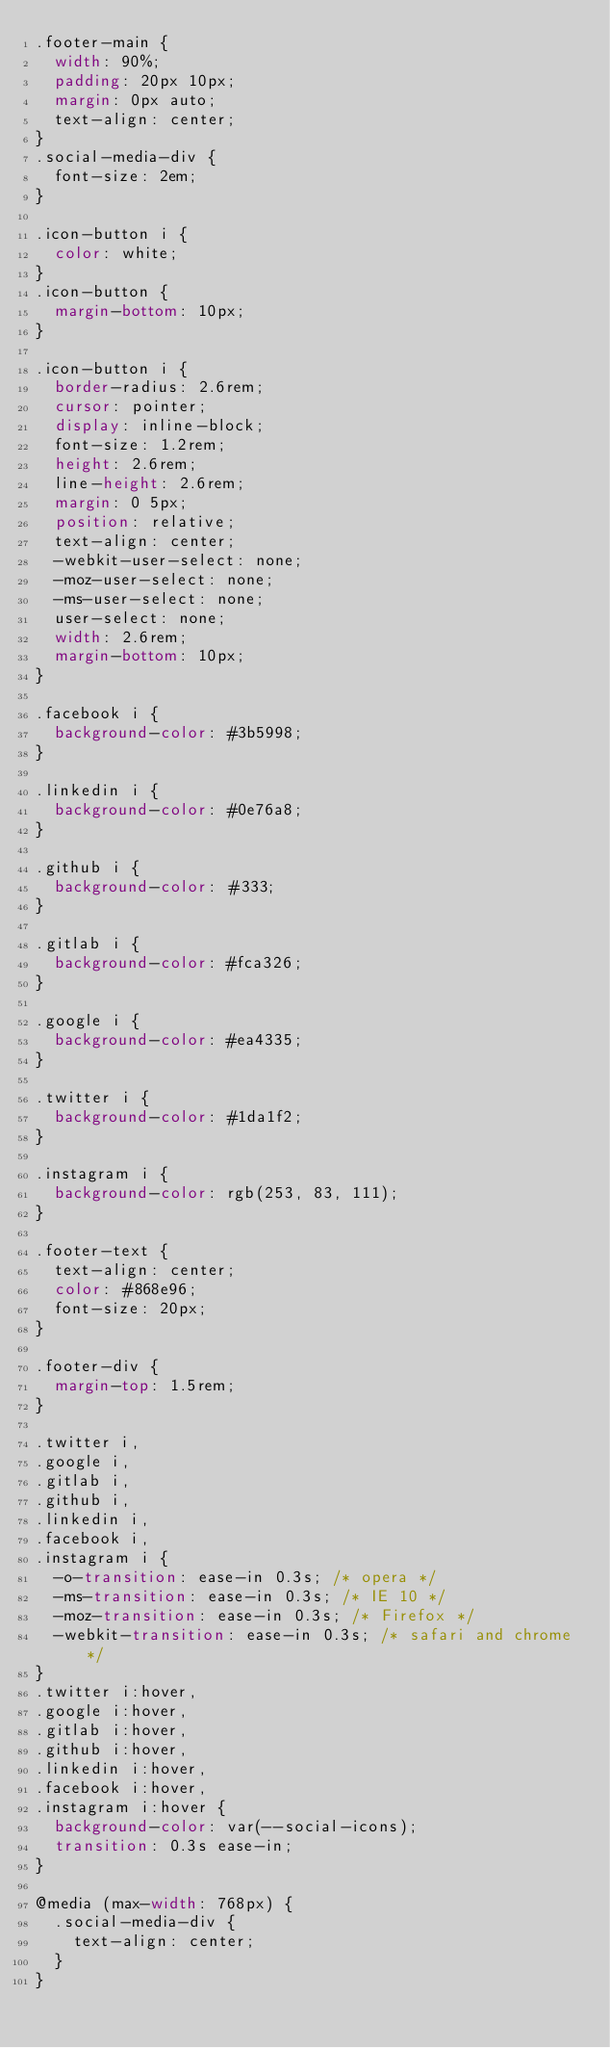<code> <loc_0><loc_0><loc_500><loc_500><_CSS_>.footer-main {
  width: 90%;
  padding: 20px 10px;
  margin: 0px auto;
  text-align: center;
}
.social-media-div {
  font-size: 2em;
}

.icon-button i {
  color: white;
}
.icon-button {
  margin-bottom: 10px;
}

.icon-button i {
  border-radius: 2.6rem;
  cursor: pointer;
  display: inline-block;
  font-size: 1.2rem;
  height: 2.6rem;
  line-height: 2.6rem;
  margin: 0 5px;
  position: relative;
  text-align: center;
  -webkit-user-select: none;
  -moz-user-select: none;
  -ms-user-select: none;
  user-select: none;
  width: 2.6rem;
  margin-bottom: 10px;
}

.facebook i {
  background-color: #3b5998;
}

.linkedin i {
  background-color: #0e76a8;
}

.github i {
  background-color: #333;
}

.gitlab i {
  background-color: #fca326;
}

.google i {
  background-color: #ea4335;
}

.twitter i {
  background-color: #1da1f2;
}

.instagram i {
  background-color: rgb(253, 83, 111);
}

.footer-text {
  text-align: center;
  color: #868e96;
  font-size: 20px;
}

.footer-div {
  margin-top: 1.5rem;
}

.twitter i,
.google i,
.gitlab i,
.github i,
.linkedin i,
.facebook i,
.instagram i {
  -o-transition: ease-in 0.3s; /* opera */
  -ms-transition: ease-in 0.3s; /* IE 10 */
  -moz-transition: ease-in 0.3s; /* Firefox */
  -webkit-transition: ease-in 0.3s; /* safari and chrome */
}
.twitter i:hover,
.google i:hover,
.gitlab i:hover,
.github i:hover,
.linkedin i:hover,
.facebook i:hover,
.instagram i:hover {
  background-color: var(--social-icons);
  transition: 0.3s ease-in;
}

@media (max-width: 768px) {
  .social-media-div {
    text-align: center;
  }
}
</code> 